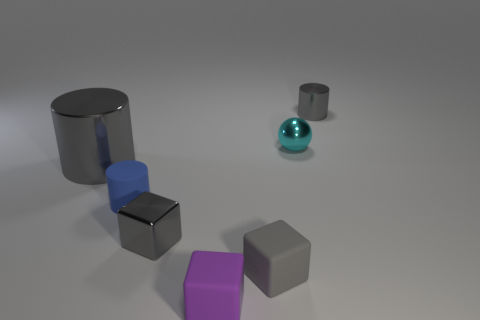What number of small green rubber cubes are there?
Provide a succinct answer. 0. Does the large cylinder have the same material as the thing that is in front of the gray rubber block?
Ensure brevity in your answer.  No. There is another small cube that is the same color as the metallic block; what is its material?
Make the answer very short. Rubber. What number of shiny cubes are the same color as the large metal object?
Provide a succinct answer. 1. Does the tiny blue rubber thing have the same shape as the tiny gray metallic object behind the small cyan metallic object?
Offer a very short reply. Yes. There is a small block that is made of the same material as the cyan object; what color is it?
Keep it short and to the point. Gray. What is the size of the gray thing behind the small cyan shiny ball?
Provide a short and direct response. Small. Is the number of balls that are in front of the gray matte thing less than the number of tiny gray metallic blocks?
Your answer should be very brief. Yes. Do the big cylinder and the metal block have the same color?
Provide a succinct answer. Yes. Are there any other things that are the same shape as the small blue matte object?
Give a very brief answer. Yes. 